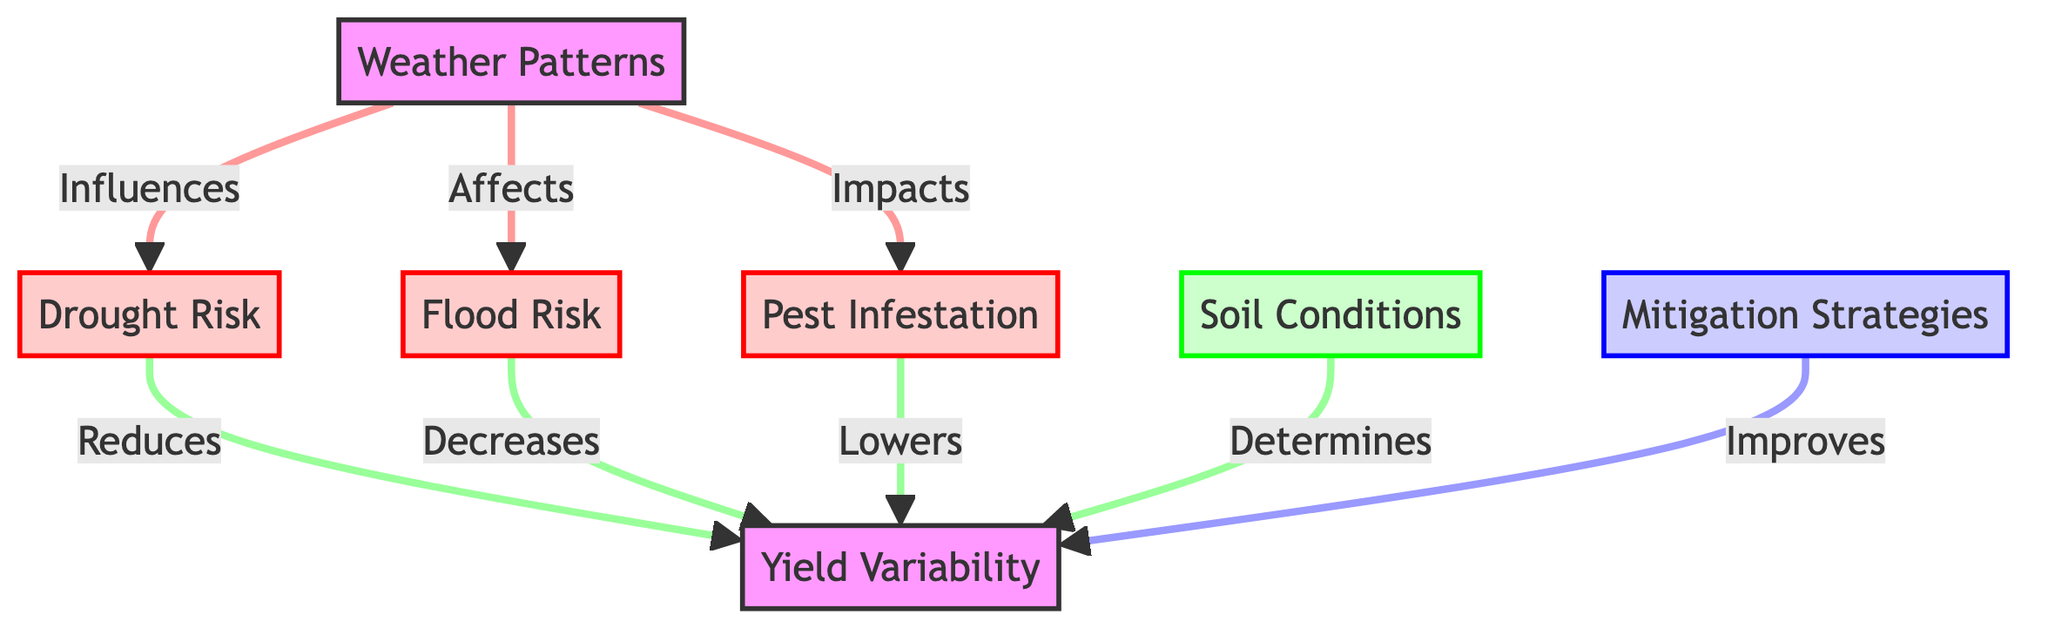What are the total number of nodes in the diagram? The diagram has eight nodes, each representing a significant concept related to weather impacts on potato yield.
Answer: Eight What does "Weather Patterns" influence? "Weather Patterns" influences "Drought Risk," "Flood Risk," and "Pest Infestation," as indicated by the directed edges stemming from this node.
Answer: Drought Risk, Flood Risk, Pest Infestation How many types of risk are shown in the diagram? The diagram depicts three types of risk: Drought Risk, Flood Risk, and Pest Infestation.
Answer: Three What effect does "Drought Risk" have on "Yield Variability"? "Drought Risk" reduces "Yield Variability," as indicated by the directed edge between these two nodes.
Answer: Reduces Which node determines "Yield Variability"? "Soil Conditions" determine "Yield Variability," as shown by the directed edge from "Soil Conditions" to "Yield Variability."
Answer: Soil Conditions What connects "Mitigation Strategies" to "Yield Variability"? "Mitigation Strategies" improves "Yield Variability," confirmed by the directed edge pointing from "Mitigation Strategies" to "Yield Variability."
Answer: Improves Which risks lead to "Yield Variability"? "Drought Risk," "Flood Risk," "Pest Infestation," and "Soil Conditions" all have directed edges leading to "Yield Variability," illustrating their impact.
Answer: Drought Risk, Flood Risk, Pest Infestation, Soil Conditions How many edges are there in total in the diagram? The diagram contains seven edges, which represent the relationships between the nodes.
Answer: Seven 